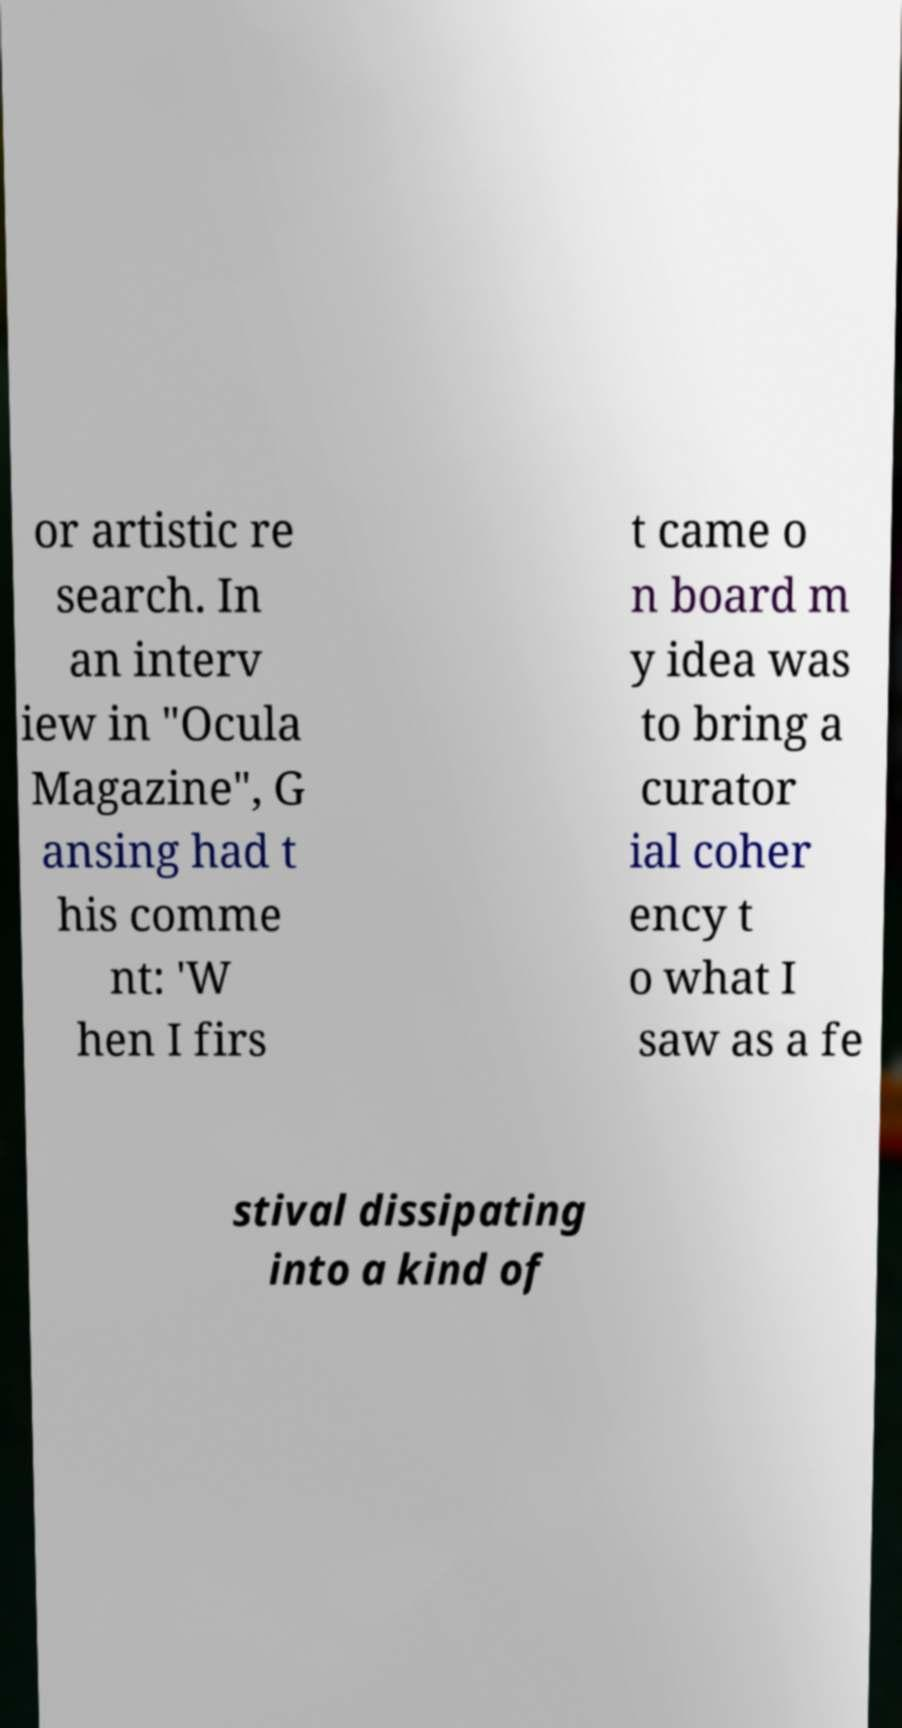What messages or text are displayed in this image? I need them in a readable, typed format. or artistic re search. In an interv iew in "Ocula Magazine", G ansing had t his comme nt: 'W hen I firs t came o n board m y idea was to bring a curator ial coher ency t o what I saw as a fe stival dissipating into a kind of 